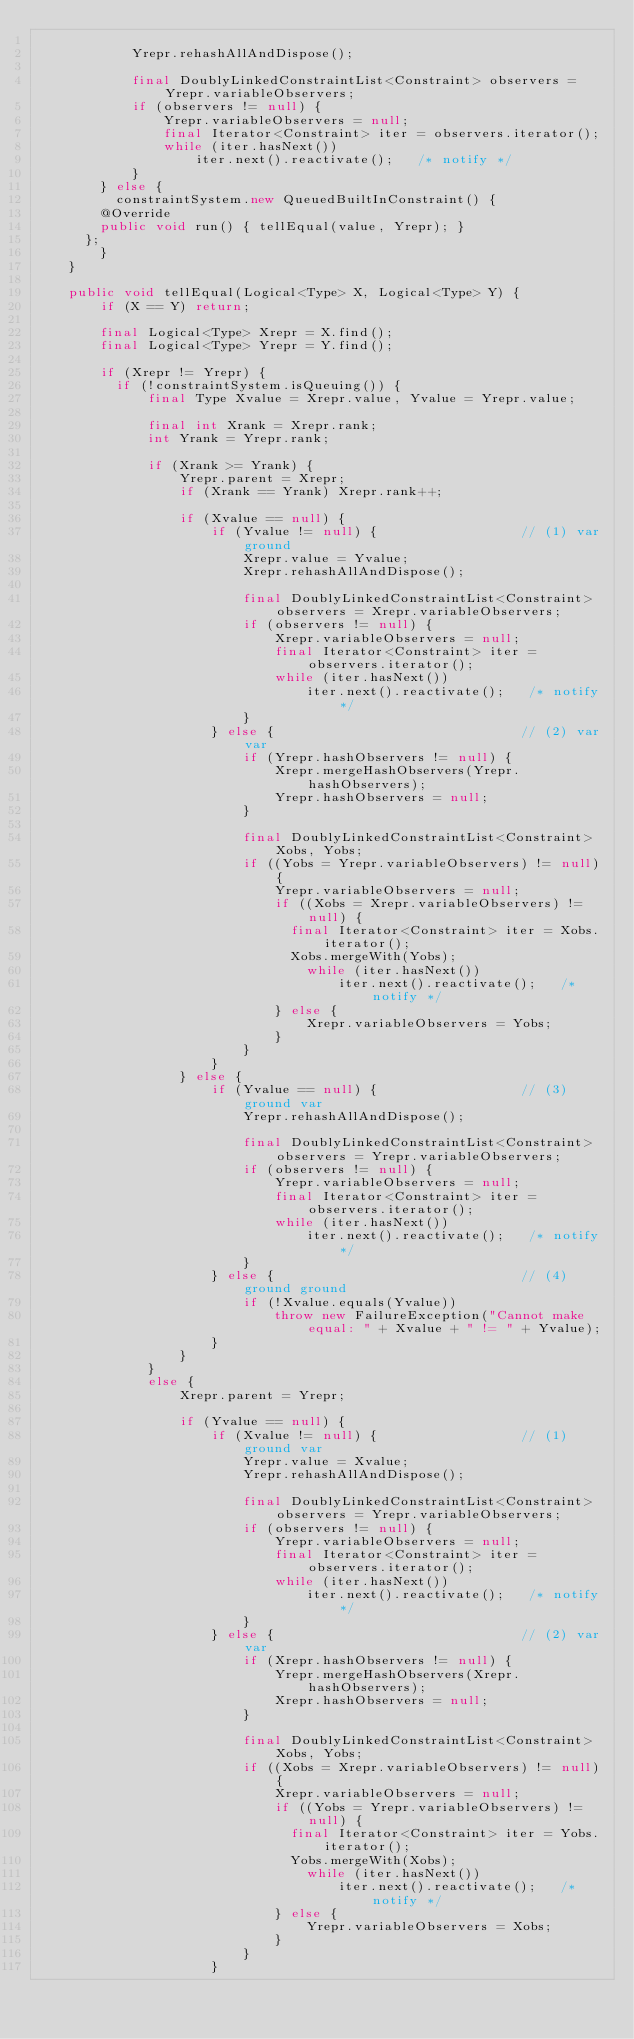<code> <loc_0><loc_0><loc_500><loc_500><_Java_>
            Yrepr.rehashAllAndDispose();
            
            final DoublyLinkedConstraintList<Constraint> observers = Yrepr.variableObservers;
            if (observers != null) {
                Yrepr.variableObservers = null;
                final Iterator<Constraint> iter = observers.iterator();
                while (iter.hasNext()) 
                    iter.next().reactivate();   /* notify */
            }
        } else {
        	constraintSystem.new QueuedBuiltInConstraint() {
				@Override
				public void run() { tellEqual(value, Yrepr); }
			};
        }
    }

    public void tellEqual(Logical<Type> X, Logical<Type> Y) {
        if (X == Y) return;
        
        final Logical<Type> Xrepr = X.find();
        final Logical<Type> Yrepr = Y.find();

        if (Xrepr != Yrepr) {
        	if (!constraintSystem.isQueuing()) {
	            final Type Xvalue = Xrepr.value, Yvalue = Yrepr.value;
	
	            final int Xrank = Xrepr.rank;
	            int Yrank = Yrepr.rank;
	
	            if (Xrank >= Yrank) {
	                Yrepr.parent = Xrepr;
	                if (Xrank == Yrank) Xrepr.rank++;
	
	                if (Xvalue == null) {
	                    if (Yvalue != null) {                  // (1) var ground
	                        Xrepr.value = Yvalue;
	                        Xrepr.rehashAllAndDispose();
	                        
	                        final DoublyLinkedConstraintList<Constraint> observers = Xrepr.variableObservers;
	                        if (observers != null) {
	                            Xrepr.variableObservers = null;
	                            final Iterator<Constraint> iter = observers.iterator();
	                            while (iter.hasNext()) 
	                                iter.next().reactivate();   /* notify */
	                        }
	                    } else {                               // (2) var var
	                        if (Yrepr.hashObservers != null) {
	                            Xrepr.mergeHashObservers(Yrepr.hashObservers);
	                            Yrepr.hashObservers = null;
	                        }
	                        
	                        final DoublyLinkedConstraintList<Constraint> Xobs, Yobs;
	                        if ((Yobs = Yrepr.variableObservers) != null) {
	                            Yrepr.variableObservers = null;
	                            if ((Xobs = Xrepr.variableObservers) != null) {
	                            	final Iterator<Constraint> iter = Xobs.iterator();
	                            	Xobs.mergeWith(Yobs);
	                                while (iter.hasNext()) 
	                                    iter.next().reactivate();   /* notify */
	                            } else {
	                                Xrepr.variableObservers = Yobs;
	                            }
	                        }
	                    }
	                } else {
	                    if (Yvalue == null) {                  // (3) ground var
	                        Yrepr.rehashAllAndDispose();
	                        
	                        final DoublyLinkedConstraintList<Constraint> observers = Yrepr.variableObservers;
	                        if (observers != null) {
	                            Yrepr.variableObservers = null;
	                            final Iterator<Constraint> iter = observers.iterator();
	                            while (iter.hasNext()) 
	                                iter.next().reactivate();   /* notify */
	                        }
	                    } else {                               // (4) ground ground
	                        if (!Xvalue.equals(Yvalue))
	                            throw new FailureException("Cannot make equal: " + Xvalue + " != " + Yvalue);
	                    }
	                }
	            }
	            else {
	                Xrepr.parent = Yrepr;
	
	                if (Yvalue == null) {
	                    if (Xvalue != null) {                  // (1) ground var 
	                        Yrepr.value = Xvalue;
	                        Yrepr.rehashAllAndDispose();
	                        
	                        final DoublyLinkedConstraintList<Constraint> observers = Yrepr.variableObservers;
	                        if (observers != null) {
	                            Yrepr.variableObservers = null;
	                            final Iterator<Constraint> iter = observers.iterator();
	                            while (iter.hasNext()) 
	                                iter.next().reactivate();   /* notify */
	                        }
	                    } else {                               // (2) var var
	                        if (Xrepr.hashObservers != null) {
	                            Yrepr.mergeHashObservers(Xrepr.hashObservers);
	                            Xrepr.hashObservers = null;
	                        }
	                        
	                        final DoublyLinkedConstraintList<Constraint> Xobs, Yobs;
	                        if ((Xobs = Xrepr.variableObservers) != null) {
	                            Xrepr.variableObservers = null;
	                            if ((Yobs = Yrepr.variableObservers) != null) {
	                            	final Iterator<Constraint> iter = Yobs.iterator();
	                            	Yobs.mergeWith(Xobs);
	                                while (iter.hasNext()) 
	                                    iter.next().reactivate();   /* notify */
	                            } else {
	                                Yrepr.variableObservers = Xobs;
	                            }
	                        }
	                    }</code> 